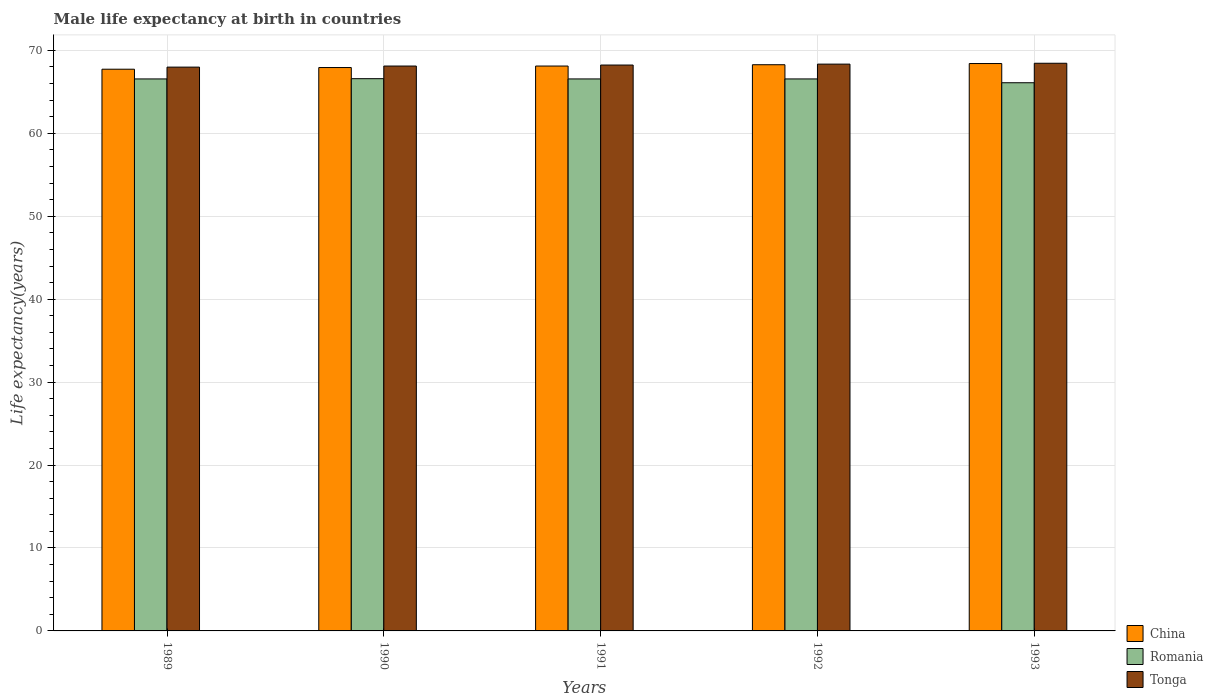How many different coloured bars are there?
Keep it short and to the point. 3. How many groups of bars are there?
Provide a short and direct response. 5. Are the number of bars per tick equal to the number of legend labels?
Offer a very short reply. Yes. Are the number of bars on each tick of the X-axis equal?
Your answer should be compact. Yes. How many bars are there on the 4th tick from the left?
Offer a very short reply. 3. How many bars are there on the 2nd tick from the right?
Your answer should be compact. 3. What is the label of the 2nd group of bars from the left?
Offer a terse response. 1990. In how many cases, is the number of bars for a given year not equal to the number of legend labels?
Make the answer very short. 0. What is the male life expectancy at birth in Romania in 1991?
Your response must be concise. 66.56. Across all years, what is the maximum male life expectancy at birth in Tonga?
Your answer should be very brief. 68.45. Across all years, what is the minimum male life expectancy at birth in China?
Your response must be concise. 67.73. In which year was the male life expectancy at birth in Romania maximum?
Provide a succinct answer. 1990. In which year was the male life expectancy at birth in Tonga minimum?
Keep it short and to the point. 1989. What is the total male life expectancy at birth in China in the graph?
Offer a very short reply. 340.47. What is the difference between the male life expectancy at birth in China in 1989 and that in 1993?
Your response must be concise. -0.69. What is the difference between the male life expectancy at birth in Romania in 1992 and the male life expectancy at birth in China in 1991?
Your response must be concise. -1.55. What is the average male life expectancy at birth in Romania per year?
Your answer should be compact. 66.47. In the year 1990, what is the difference between the male life expectancy at birth in Tonga and male life expectancy at birth in China?
Provide a succinct answer. 0.18. In how many years, is the male life expectancy at birth in Romania greater than 40 years?
Ensure brevity in your answer.  5. What is the ratio of the male life expectancy at birth in Tonga in 1991 to that in 1993?
Offer a very short reply. 1. Is the difference between the male life expectancy at birth in Tonga in 1989 and 1993 greater than the difference between the male life expectancy at birth in China in 1989 and 1993?
Give a very brief answer. Yes. What is the difference between the highest and the second highest male life expectancy at birth in Tonga?
Ensure brevity in your answer.  0.1. What is the difference between the highest and the lowest male life expectancy at birth in Tonga?
Your response must be concise. 0.47. What does the 1st bar from the left in 1992 represents?
Make the answer very short. China. Is it the case that in every year, the sum of the male life expectancy at birth in Romania and male life expectancy at birth in China is greater than the male life expectancy at birth in Tonga?
Provide a short and direct response. Yes. How many bars are there?
Provide a succinct answer. 15. How many years are there in the graph?
Ensure brevity in your answer.  5. Does the graph contain any zero values?
Give a very brief answer. No. Does the graph contain grids?
Give a very brief answer. Yes. How are the legend labels stacked?
Provide a short and direct response. Vertical. What is the title of the graph?
Make the answer very short. Male life expectancy at birth in countries. What is the label or title of the Y-axis?
Keep it short and to the point. Life expectancy(years). What is the Life expectancy(years) in China in 1989?
Provide a short and direct response. 67.73. What is the Life expectancy(years) in Romania in 1989?
Offer a very short reply. 66.56. What is the Life expectancy(years) of Tonga in 1989?
Your response must be concise. 67.98. What is the Life expectancy(years) in China in 1990?
Your answer should be very brief. 67.93. What is the Life expectancy(years) of Romania in 1990?
Offer a terse response. 66.59. What is the Life expectancy(years) of Tonga in 1990?
Keep it short and to the point. 68.11. What is the Life expectancy(years) in China in 1991?
Provide a succinct answer. 68.11. What is the Life expectancy(years) of Romania in 1991?
Make the answer very short. 66.56. What is the Life expectancy(years) in Tonga in 1991?
Your response must be concise. 68.23. What is the Life expectancy(years) in China in 1992?
Provide a succinct answer. 68.27. What is the Life expectancy(years) in Romania in 1992?
Provide a succinct answer. 66.56. What is the Life expectancy(years) of Tonga in 1992?
Offer a very short reply. 68.35. What is the Life expectancy(years) of China in 1993?
Your response must be concise. 68.42. What is the Life expectancy(years) in Romania in 1993?
Your answer should be compact. 66.1. What is the Life expectancy(years) of Tonga in 1993?
Offer a terse response. 68.45. Across all years, what is the maximum Life expectancy(years) in China?
Make the answer very short. 68.42. Across all years, what is the maximum Life expectancy(years) in Romania?
Keep it short and to the point. 66.59. Across all years, what is the maximum Life expectancy(years) in Tonga?
Ensure brevity in your answer.  68.45. Across all years, what is the minimum Life expectancy(years) of China?
Provide a short and direct response. 67.73. Across all years, what is the minimum Life expectancy(years) in Romania?
Ensure brevity in your answer.  66.1. Across all years, what is the minimum Life expectancy(years) in Tonga?
Offer a terse response. 67.98. What is the total Life expectancy(years) in China in the graph?
Keep it short and to the point. 340.47. What is the total Life expectancy(years) in Romania in the graph?
Your response must be concise. 332.37. What is the total Life expectancy(years) of Tonga in the graph?
Offer a terse response. 341.13. What is the difference between the Life expectancy(years) in China in 1989 and that in 1990?
Ensure brevity in your answer.  -0.2. What is the difference between the Life expectancy(years) in Romania in 1989 and that in 1990?
Give a very brief answer. -0.03. What is the difference between the Life expectancy(years) of Tonga in 1989 and that in 1990?
Keep it short and to the point. -0.13. What is the difference between the Life expectancy(years) in China in 1989 and that in 1991?
Keep it short and to the point. -0.38. What is the difference between the Life expectancy(years) in Tonga in 1989 and that in 1991?
Provide a short and direct response. -0.25. What is the difference between the Life expectancy(years) in China in 1989 and that in 1992?
Provide a succinct answer. -0.54. What is the difference between the Life expectancy(years) in Romania in 1989 and that in 1992?
Provide a succinct answer. 0. What is the difference between the Life expectancy(years) of Tonga in 1989 and that in 1992?
Give a very brief answer. -0.36. What is the difference between the Life expectancy(years) of China in 1989 and that in 1993?
Offer a very short reply. -0.69. What is the difference between the Life expectancy(years) in Romania in 1989 and that in 1993?
Offer a terse response. 0.46. What is the difference between the Life expectancy(years) of Tonga in 1989 and that in 1993?
Provide a succinct answer. -0.47. What is the difference between the Life expectancy(years) of China in 1990 and that in 1991?
Offer a terse response. -0.18. What is the difference between the Life expectancy(years) of Romania in 1990 and that in 1991?
Give a very brief answer. 0.03. What is the difference between the Life expectancy(years) in Tonga in 1990 and that in 1991?
Your response must be concise. -0.12. What is the difference between the Life expectancy(years) in China in 1990 and that in 1992?
Provide a short and direct response. -0.34. What is the difference between the Life expectancy(years) in Tonga in 1990 and that in 1992?
Your response must be concise. -0.23. What is the difference between the Life expectancy(years) of China in 1990 and that in 1993?
Ensure brevity in your answer.  -0.48. What is the difference between the Life expectancy(years) of Romania in 1990 and that in 1993?
Your answer should be compact. 0.49. What is the difference between the Life expectancy(years) in Tonga in 1990 and that in 1993?
Offer a terse response. -0.34. What is the difference between the Life expectancy(years) in China in 1991 and that in 1992?
Keep it short and to the point. -0.16. What is the difference between the Life expectancy(years) of Tonga in 1991 and that in 1992?
Your answer should be very brief. -0.11. What is the difference between the Life expectancy(years) in China in 1991 and that in 1993?
Ensure brevity in your answer.  -0.3. What is the difference between the Life expectancy(years) in Romania in 1991 and that in 1993?
Provide a short and direct response. 0.46. What is the difference between the Life expectancy(years) in Tonga in 1991 and that in 1993?
Offer a terse response. -0.21. What is the difference between the Life expectancy(years) in China in 1992 and that in 1993?
Provide a succinct answer. -0.14. What is the difference between the Life expectancy(years) in Romania in 1992 and that in 1993?
Make the answer very short. 0.46. What is the difference between the Life expectancy(years) of Tonga in 1992 and that in 1993?
Provide a short and direct response. -0.1. What is the difference between the Life expectancy(years) in China in 1989 and the Life expectancy(years) in Romania in 1990?
Offer a very short reply. 1.14. What is the difference between the Life expectancy(years) in China in 1989 and the Life expectancy(years) in Tonga in 1990?
Ensure brevity in your answer.  -0.38. What is the difference between the Life expectancy(years) of Romania in 1989 and the Life expectancy(years) of Tonga in 1990?
Offer a terse response. -1.55. What is the difference between the Life expectancy(years) in China in 1989 and the Life expectancy(years) in Romania in 1991?
Give a very brief answer. 1.17. What is the difference between the Life expectancy(years) of China in 1989 and the Life expectancy(years) of Tonga in 1991?
Provide a short and direct response. -0.5. What is the difference between the Life expectancy(years) in Romania in 1989 and the Life expectancy(years) in Tonga in 1991?
Your answer should be compact. -1.68. What is the difference between the Life expectancy(years) of China in 1989 and the Life expectancy(years) of Romania in 1992?
Your answer should be compact. 1.17. What is the difference between the Life expectancy(years) in China in 1989 and the Life expectancy(years) in Tonga in 1992?
Make the answer very short. -0.61. What is the difference between the Life expectancy(years) in Romania in 1989 and the Life expectancy(years) in Tonga in 1992?
Give a very brief answer. -1.79. What is the difference between the Life expectancy(years) in China in 1989 and the Life expectancy(years) in Romania in 1993?
Keep it short and to the point. 1.63. What is the difference between the Life expectancy(years) in China in 1989 and the Life expectancy(years) in Tonga in 1993?
Give a very brief answer. -0.72. What is the difference between the Life expectancy(years) in Romania in 1989 and the Life expectancy(years) in Tonga in 1993?
Offer a very short reply. -1.89. What is the difference between the Life expectancy(years) in China in 1990 and the Life expectancy(years) in Romania in 1991?
Your answer should be compact. 1.37. What is the difference between the Life expectancy(years) in China in 1990 and the Life expectancy(years) in Tonga in 1991?
Your answer should be compact. -0.3. What is the difference between the Life expectancy(years) of Romania in 1990 and the Life expectancy(years) of Tonga in 1991?
Keep it short and to the point. -1.65. What is the difference between the Life expectancy(years) in China in 1990 and the Life expectancy(years) in Romania in 1992?
Provide a short and direct response. 1.37. What is the difference between the Life expectancy(years) in China in 1990 and the Life expectancy(years) in Tonga in 1992?
Give a very brief answer. -0.41. What is the difference between the Life expectancy(years) of Romania in 1990 and the Life expectancy(years) of Tonga in 1992?
Your response must be concise. -1.76. What is the difference between the Life expectancy(years) in China in 1990 and the Life expectancy(years) in Romania in 1993?
Your answer should be compact. 1.83. What is the difference between the Life expectancy(years) of China in 1990 and the Life expectancy(years) of Tonga in 1993?
Offer a terse response. -0.52. What is the difference between the Life expectancy(years) in Romania in 1990 and the Life expectancy(years) in Tonga in 1993?
Offer a very short reply. -1.86. What is the difference between the Life expectancy(years) of China in 1991 and the Life expectancy(years) of Romania in 1992?
Provide a succinct answer. 1.55. What is the difference between the Life expectancy(years) in China in 1991 and the Life expectancy(years) in Tonga in 1992?
Keep it short and to the point. -0.23. What is the difference between the Life expectancy(years) in Romania in 1991 and the Life expectancy(years) in Tonga in 1992?
Your answer should be compact. -1.79. What is the difference between the Life expectancy(years) of China in 1991 and the Life expectancy(years) of Romania in 1993?
Your response must be concise. 2.01. What is the difference between the Life expectancy(years) in China in 1991 and the Life expectancy(years) in Tonga in 1993?
Give a very brief answer. -0.34. What is the difference between the Life expectancy(years) in Romania in 1991 and the Life expectancy(years) in Tonga in 1993?
Give a very brief answer. -1.89. What is the difference between the Life expectancy(years) in China in 1992 and the Life expectancy(years) in Romania in 1993?
Offer a very short reply. 2.17. What is the difference between the Life expectancy(years) in China in 1992 and the Life expectancy(years) in Tonga in 1993?
Keep it short and to the point. -0.18. What is the difference between the Life expectancy(years) in Romania in 1992 and the Life expectancy(years) in Tonga in 1993?
Ensure brevity in your answer.  -1.89. What is the average Life expectancy(years) of China per year?
Provide a succinct answer. 68.09. What is the average Life expectancy(years) in Romania per year?
Keep it short and to the point. 66.47. What is the average Life expectancy(years) of Tonga per year?
Your answer should be very brief. 68.23. In the year 1989, what is the difference between the Life expectancy(years) in China and Life expectancy(years) in Romania?
Your answer should be very brief. 1.17. In the year 1989, what is the difference between the Life expectancy(years) of China and Life expectancy(years) of Tonga?
Your answer should be very brief. -0.25. In the year 1989, what is the difference between the Life expectancy(years) in Romania and Life expectancy(years) in Tonga?
Your response must be concise. -1.43. In the year 1990, what is the difference between the Life expectancy(years) of China and Life expectancy(years) of Romania?
Your answer should be compact. 1.34. In the year 1990, what is the difference between the Life expectancy(years) of China and Life expectancy(years) of Tonga?
Give a very brief answer. -0.18. In the year 1990, what is the difference between the Life expectancy(years) in Romania and Life expectancy(years) in Tonga?
Make the answer very short. -1.52. In the year 1991, what is the difference between the Life expectancy(years) in China and Life expectancy(years) in Romania?
Your answer should be very brief. 1.55. In the year 1991, what is the difference between the Life expectancy(years) in China and Life expectancy(years) in Tonga?
Keep it short and to the point. -0.12. In the year 1991, what is the difference between the Life expectancy(years) in Romania and Life expectancy(years) in Tonga?
Keep it short and to the point. -1.68. In the year 1992, what is the difference between the Life expectancy(years) of China and Life expectancy(years) of Romania?
Your response must be concise. 1.71. In the year 1992, what is the difference between the Life expectancy(years) of China and Life expectancy(years) of Tonga?
Your answer should be compact. -0.07. In the year 1992, what is the difference between the Life expectancy(years) of Romania and Life expectancy(years) of Tonga?
Your response must be concise. -1.79. In the year 1993, what is the difference between the Life expectancy(years) of China and Life expectancy(years) of Romania?
Give a very brief answer. 2.32. In the year 1993, what is the difference between the Life expectancy(years) of China and Life expectancy(years) of Tonga?
Offer a terse response. -0.03. In the year 1993, what is the difference between the Life expectancy(years) in Romania and Life expectancy(years) in Tonga?
Offer a very short reply. -2.35. What is the ratio of the Life expectancy(years) of China in 1989 to that in 1990?
Provide a short and direct response. 1. What is the ratio of the Life expectancy(years) of Tonga in 1989 to that in 1990?
Offer a very short reply. 1. What is the ratio of the Life expectancy(years) in Romania in 1989 to that in 1991?
Give a very brief answer. 1. What is the ratio of the Life expectancy(years) of China in 1989 to that in 1992?
Your response must be concise. 0.99. What is the ratio of the Life expectancy(years) of Romania in 1989 to that in 1992?
Provide a short and direct response. 1. What is the ratio of the Life expectancy(years) in Tonga in 1989 to that in 1992?
Provide a succinct answer. 0.99. What is the ratio of the Life expectancy(years) of China in 1989 to that in 1993?
Provide a succinct answer. 0.99. What is the ratio of the Life expectancy(years) in Tonga in 1989 to that in 1993?
Provide a succinct answer. 0.99. What is the ratio of the Life expectancy(years) in Tonga in 1990 to that in 1991?
Provide a short and direct response. 1. What is the ratio of the Life expectancy(years) in Romania in 1990 to that in 1992?
Your response must be concise. 1. What is the ratio of the Life expectancy(years) in Tonga in 1990 to that in 1992?
Your answer should be compact. 1. What is the ratio of the Life expectancy(years) in China in 1990 to that in 1993?
Give a very brief answer. 0.99. What is the ratio of the Life expectancy(years) in Romania in 1990 to that in 1993?
Keep it short and to the point. 1.01. What is the ratio of the Life expectancy(years) in Tonga in 1990 to that in 1993?
Your response must be concise. 1. What is the ratio of the Life expectancy(years) of Tonga in 1991 to that in 1992?
Provide a succinct answer. 1. What is the ratio of the Life expectancy(years) of Tonga in 1991 to that in 1993?
Keep it short and to the point. 1. What is the ratio of the Life expectancy(years) of China in 1992 to that in 1993?
Give a very brief answer. 1. What is the ratio of the Life expectancy(years) in Romania in 1992 to that in 1993?
Your response must be concise. 1.01. What is the difference between the highest and the second highest Life expectancy(years) of China?
Keep it short and to the point. 0.14. What is the difference between the highest and the second highest Life expectancy(years) in Tonga?
Give a very brief answer. 0.1. What is the difference between the highest and the lowest Life expectancy(years) of China?
Your answer should be very brief. 0.69. What is the difference between the highest and the lowest Life expectancy(years) of Romania?
Provide a short and direct response. 0.49. What is the difference between the highest and the lowest Life expectancy(years) of Tonga?
Offer a terse response. 0.47. 